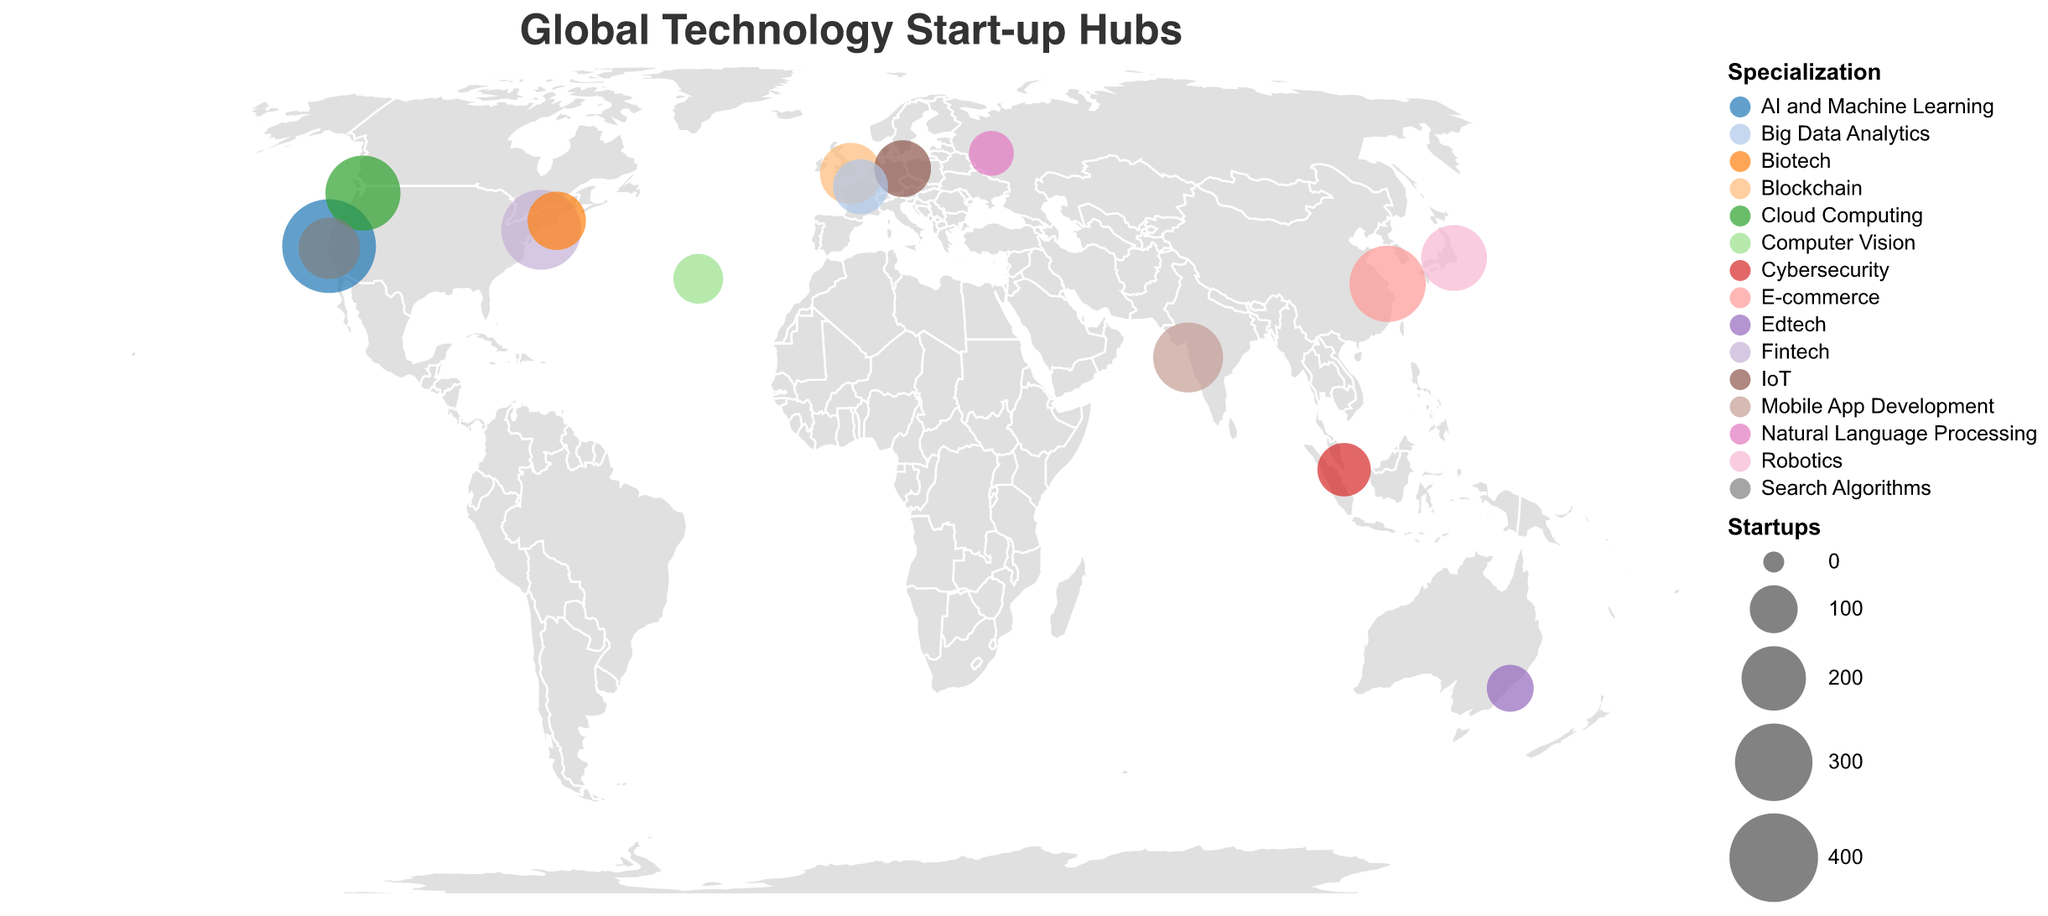Which city has the highest number of startups? The city with the largest circle in the plot, representing 450 startups, is San Francisco.
Answer: San Francisco What is the specialization of the start-up hub in Mountain View? Hovering or looking closely at the Mountain View point in the figure reveals it specializes in Search Algorithms.
Answer: Search Algorithms How many start-up hubs are located in the USA? The plot shows cities in the USA with visible startup hubs: San Francisco, Seattle, New York City, Mountain View, and Boston, tallying to five.
Answer: 5 Which city in Europe has the most startups? Observing the European cities, London has a larger circle compared to Berlin, Paris, and Moscow. London has 180 startups.
Answer: London What types of specializations are found in Asia according to the plot? The map shows Tokyo specializing in Robotics, Shanghai in E-commerce, and Singapore in Cybersecurity.
Answer: Robotics, E-commerce, Cybersecurity Among the cities shown in the USA, which one specializes in Biotech? Boston is the city specializing in Biotech, which is visible from the tooltip of the Boston circle.
Answer: Boston Is there any city specializing in Blockchain, and if so, what is the number of startups there? By scanning the plot, the tooltip for London shows it specializes in Blockchain with 180 startups.
Answer: Yes, 180 Compare the number of startups in Seattle and New York City. Which has more? Referring to the sizes of circles for both cities, New York City has 320 startups, while Seattle has 280 startups. Therefore, New York City has more.
Answer: New York City What is the average number of startups for the cities displayed on the map? Adding up all startups (450 + 280 + 320 + 180 + 150 + 210 + 290 + 130 + 95 + 240 + 180 + 160 + 140 + 110 + 85) yields 3020. Dividing by the 15 cities gives 3020/15 ≈ 201.33.
Answer: 201.33 Which city has the smallest number of startups, and what is its specialization? By noting the smallest circle, Moscow has 85 startups and specializes in Natural Language Processing.
Answer: Moscow, Natural Language Processing 